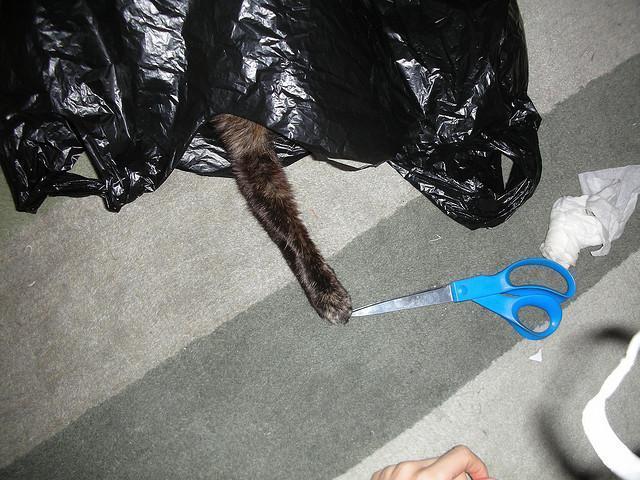How many hands are in the picture?
Give a very brief answer. 1. 